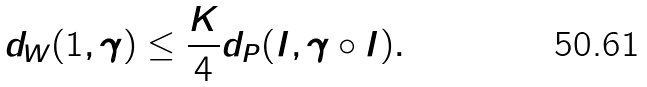<formula> <loc_0><loc_0><loc_500><loc_500>d _ { W } ( 1 , \gamma ) \leq \frac { K } { 4 } d _ { P } ( I , \gamma \circ I ) .</formula> 